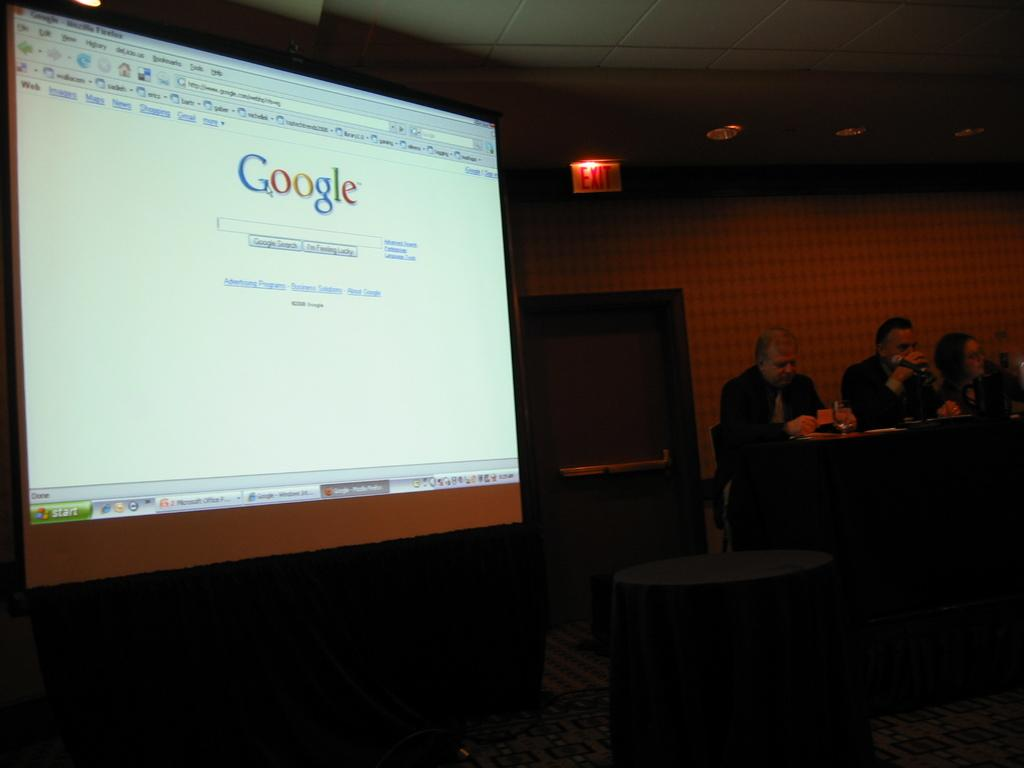How many people are in the image? There is a group of people in the image. What are the people doing in the image? The people are sitting in chairs. Where are the chairs located in relation to the table? The chairs are near a table. What items can be seen on the table? There are glasses and papers on the table. What objects can be seen in the background of the image? There is a screen, a door, a name board, and a light in the background. What type of baseball game is being played in the image? There is no baseball game present in the image. Is there a volcano erupting in the background of the image? There is no volcano present in the image. 